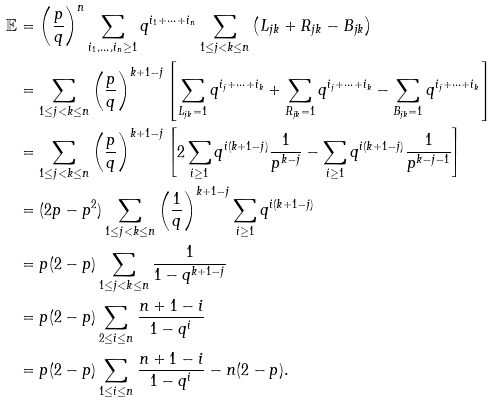Convert formula to latex. <formula><loc_0><loc_0><loc_500><loc_500>\mathbb { E } & = \left ( \frac { p } { q } \right ) ^ { n } \sum _ { i _ { 1 } , \dots , i _ { n } \geq 1 } q ^ { i _ { 1 } + \dots + i _ { n } } \sum _ { 1 \leq j < k \leq n } \left ( L _ { j k } + R _ { j k } - B _ { j k } \right ) \\ & = \sum _ { 1 \leq j < k \leq n } \left ( \frac { p } { q } \right ) ^ { k + 1 - j } \left [ \sum _ { L _ { j k } = 1 } q ^ { i _ { j } + \dots + i _ { k } } + \sum _ { R _ { j k } = 1 } q ^ { i _ { j } + \dots + i _ { k } } - \sum _ { B _ { j k } = 1 } q ^ { i _ { j } + \dots + i _ { k } } \right ] \\ & = \sum _ { 1 \leq j < k \leq n } \left ( \frac { p } { q } \right ) ^ { k + 1 - j } \left [ 2 \sum _ { i \geq 1 } q ^ { i ( k + 1 - j ) } \frac { 1 } { p ^ { k - j } } - \sum _ { i \geq 1 } q ^ { i ( k + 1 - j ) } \frac { 1 } { p ^ { k - j - 1 } } \right ] \\ & = ( 2 p - p ^ { 2 } ) \sum _ { 1 \leq j < k \leq n } \left ( \frac { 1 } { q } \right ) ^ { k + 1 - j } \sum _ { i \geq 1 } q ^ { i ( k + 1 - j ) } \\ & = p ( 2 - p ) \sum _ { 1 \leq j < k \leq n } \frac { 1 } { 1 - q ^ { k + 1 - j } } \\ & = p ( 2 - p ) \sum _ { 2 \leq i \leq n } \frac { n + 1 - i } { 1 - q ^ { i } } \\ & = p ( 2 - p ) \sum _ { 1 \leq i \leq n } \frac { n + 1 - i } { 1 - q ^ { i } } - n ( 2 - p ) .</formula> 